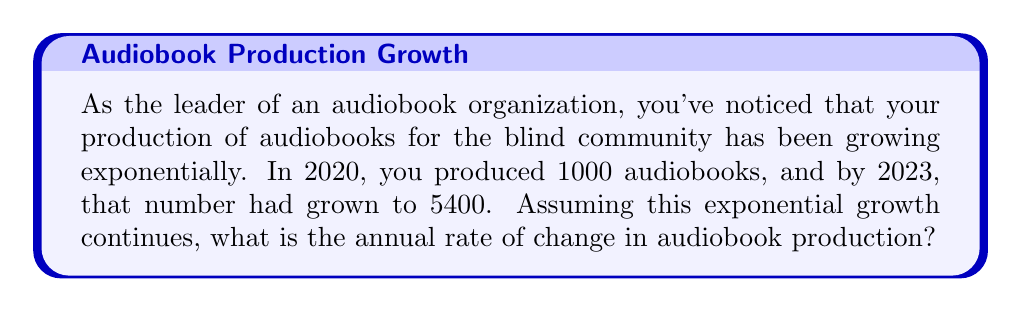Can you answer this question? Let's approach this step-by-step:

1) The exponential growth function has the form $A(t) = A_0 \cdot (1+r)^t$, where:
   $A(t)$ is the amount at time $t$
   $A_0$ is the initial amount
   $r$ is the annual rate of change
   $t$ is the time in years

2) We know:
   $A_0 = 1000$ (initial production in 2020)
   $A(3) = 5400$ (production after 3 years, in 2023)

3) Let's plug these into our equation:
   $5400 = 1000 \cdot (1+r)^3$

4) Divide both sides by 1000:
   $5.4 = (1+r)^3$

5) Take the cube root of both sides:
   $\sqrt[3]{5.4} = 1+r$

6) Subtract 1 from both sides:
   $\sqrt[3]{5.4} - 1 = r$

7) Calculate:
   $r \approx 1.75 - 1 = 0.75$

8) Convert to percentage:
   $r \approx 0.75 = 75\%$

Therefore, the annual rate of change is approximately 75%.
Answer: 75% 